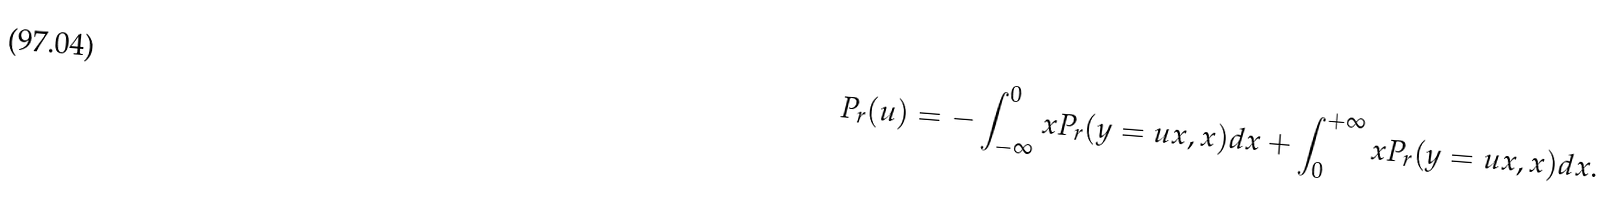Convert formula to latex. <formula><loc_0><loc_0><loc_500><loc_500>P _ { r } ( u ) = - \int _ { - \infty } ^ { 0 } x P _ { r } ( y = u x , x ) d x + \int _ { 0 } ^ { + \infty } x P _ { r } ( y = u x , x ) d x .</formula> 